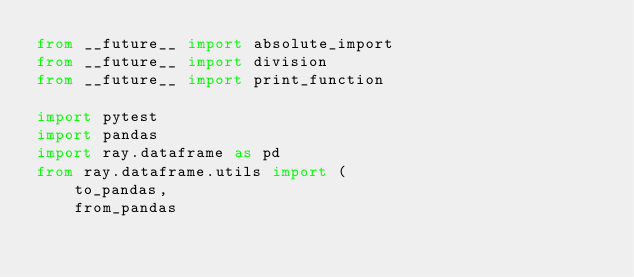Convert code to text. <code><loc_0><loc_0><loc_500><loc_500><_Python_>from __future__ import absolute_import
from __future__ import division
from __future__ import print_function

import pytest
import pandas
import ray.dataframe as pd
from ray.dataframe.utils import (
    to_pandas,
    from_pandas</code> 